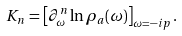<formula> <loc_0><loc_0><loc_500><loc_500>K _ { n } = \left [ \partial _ { \omega } ^ { n } \ln \rho _ { a } ( \omega ) \right ] _ { \omega = - i p } .</formula> 